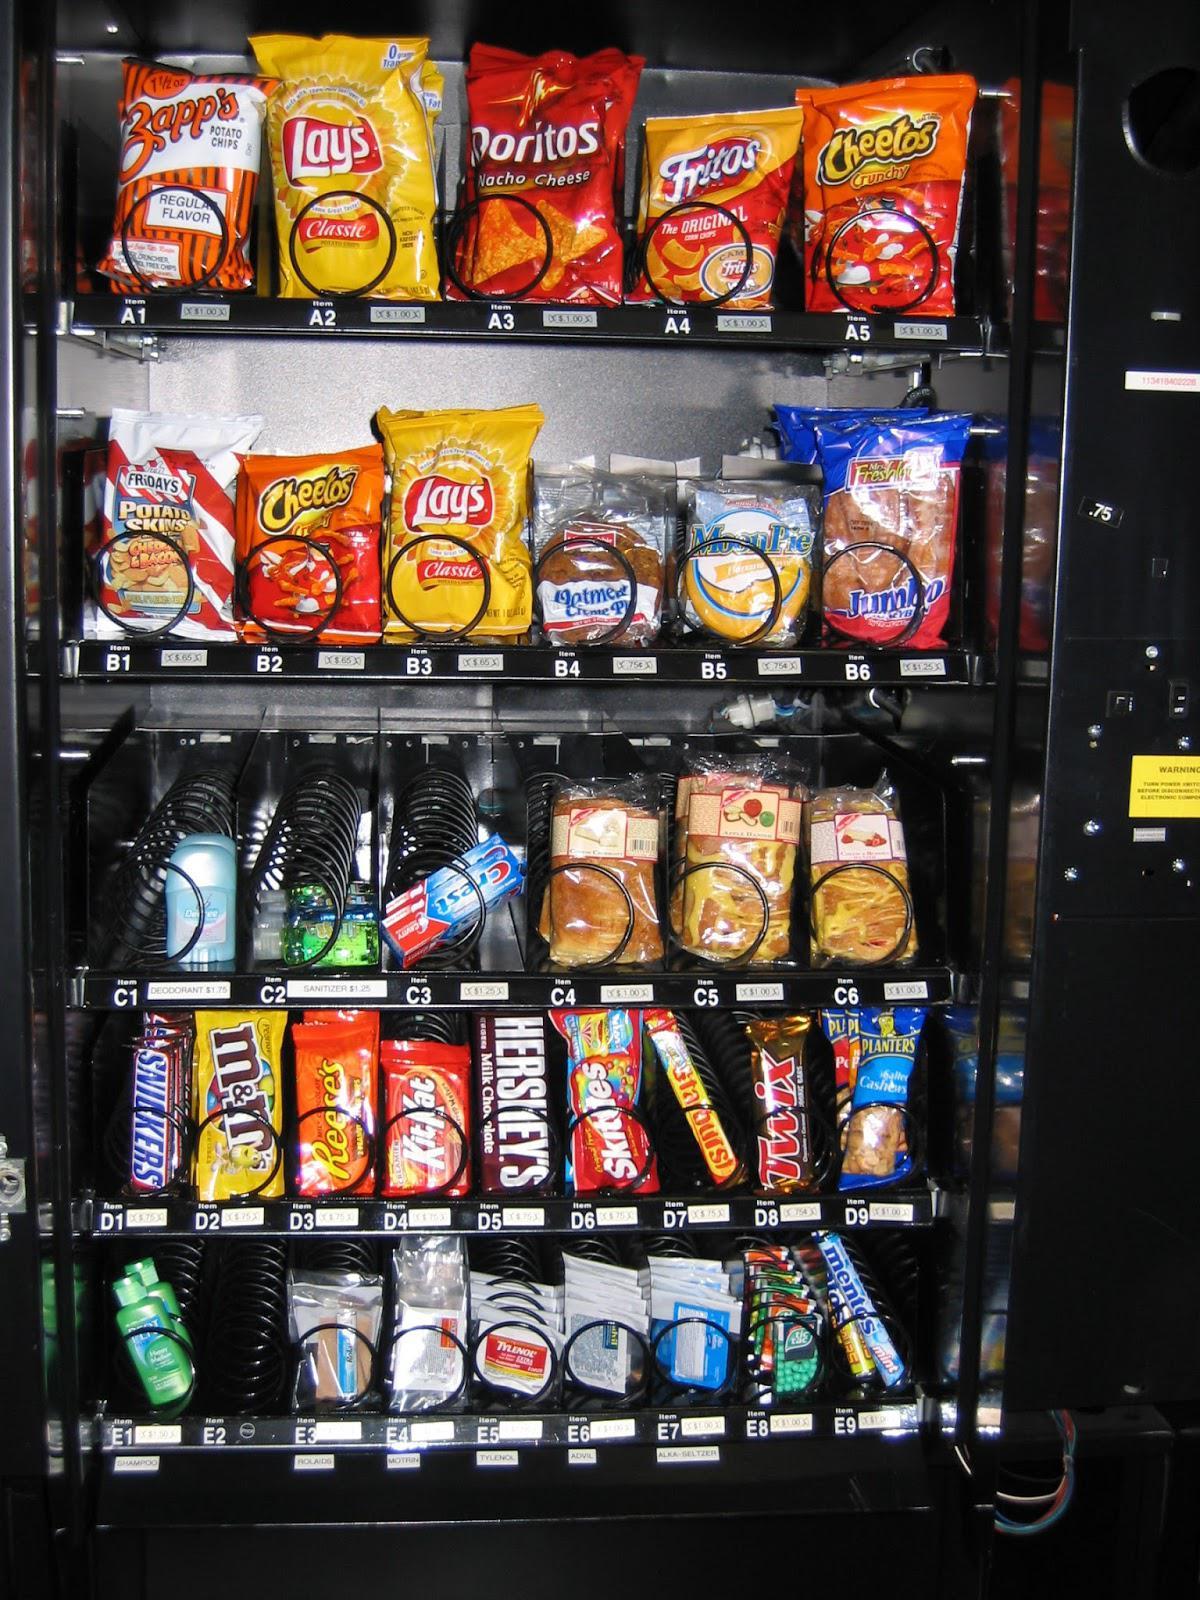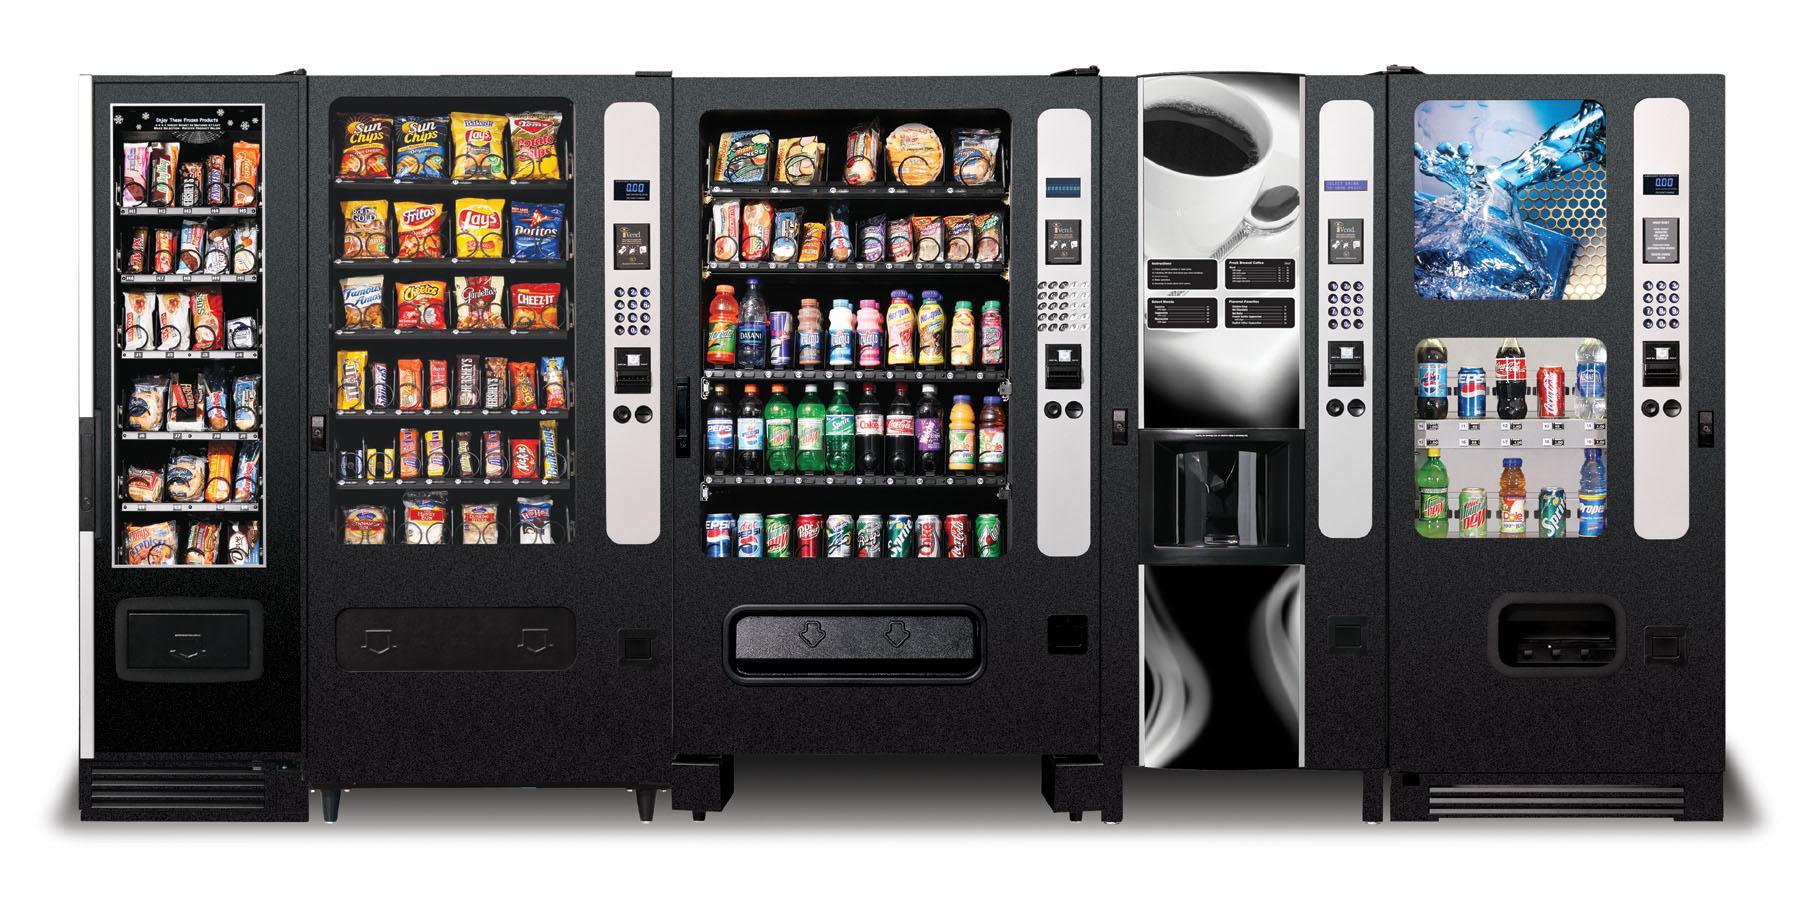The first image is the image on the left, the second image is the image on the right. Given the left and right images, does the statement "The dispensing port of the vending machine in the image on the left is outlined by a gray rectangle." hold true? Answer yes or no. No. 